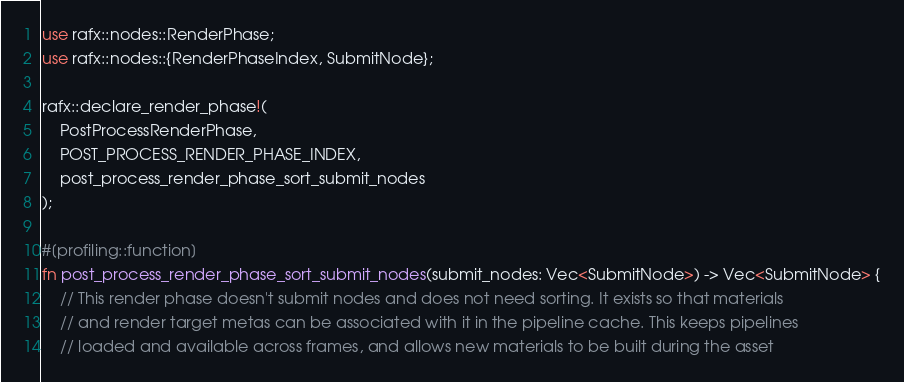<code> <loc_0><loc_0><loc_500><loc_500><_Rust_>use rafx::nodes::RenderPhase;
use rafx::nodes::{RenderPhaseIndex, SubmitNode};

rafx::declare_render_phase!(
    PostProcessRenderPhase,
    POST_PROCESS_RENDER_PHASE_INDEX,
    post_process_render_phase_sort_submit_nodes
);

#[profiling::function]
fn post_process_render_phase_sort_submit_nodes(submit_nodes: Vec<SubmitNode>) -> Vec<SubmitNode> {
    // This render phase doesn't submit nodes and does not need sorting. It exists so that materials
    // and render target metas can be associated with it in the pipeline cache. This keeps pipelines
    // loaded and available across frames, and allows new materials to be built during the asset</code> 